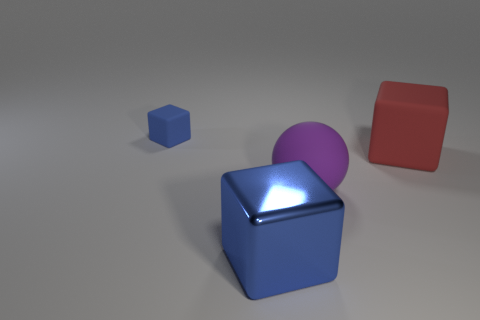What material is the large cube that is the same color as the tiny cube?
Give a very brief answer. Metal. Is there anything else that has the same size as the blue rubber cube?
Provide a short and direct response. No. What color is the other rubber object that is the same shape as the red matte object?
Make the answer very short. Blue. Is there anything else that is the same shape as the purple thing?
Offer a terse response. No. Is the number of large balls greater than the number of big gray metal cylinders?
Ensure brevity in your answer.  Yes. How many other things are made of the same material as the large red object?
Provide a short and direct response. 2. What is the shape of the blue object behind the blue thing in front of the matte cube that is behind the red thing?
Your answer should be very brief. Cube. Is the number of big purple objects that are on the left side of the small blue rubber cube less than the number of purple balls that are in front of the red object?
Make the answer very short. Yes. Are there any other objects of the same color as the shiny thing?
Give a very brief answer. Yes. Does the red object have the same material as the blue thing that is behind the sphere?
Your answer should be very brief. Yes. 